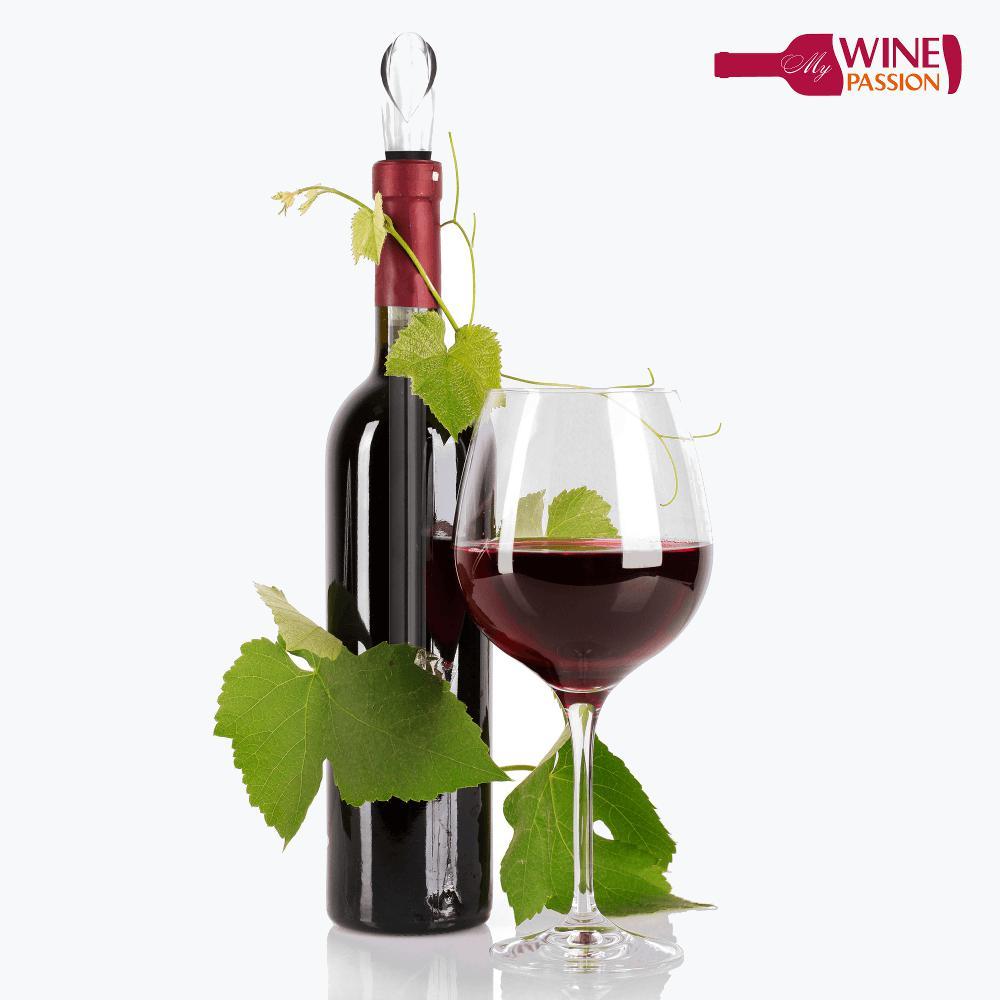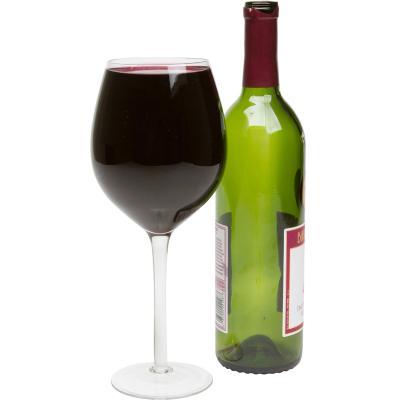The first image is the image on the left, the second image is the image on the right. For the images displayed, is the sentence "One of the images has exactly three partially filled glasses." factually correct? Answer yes or no. No. 